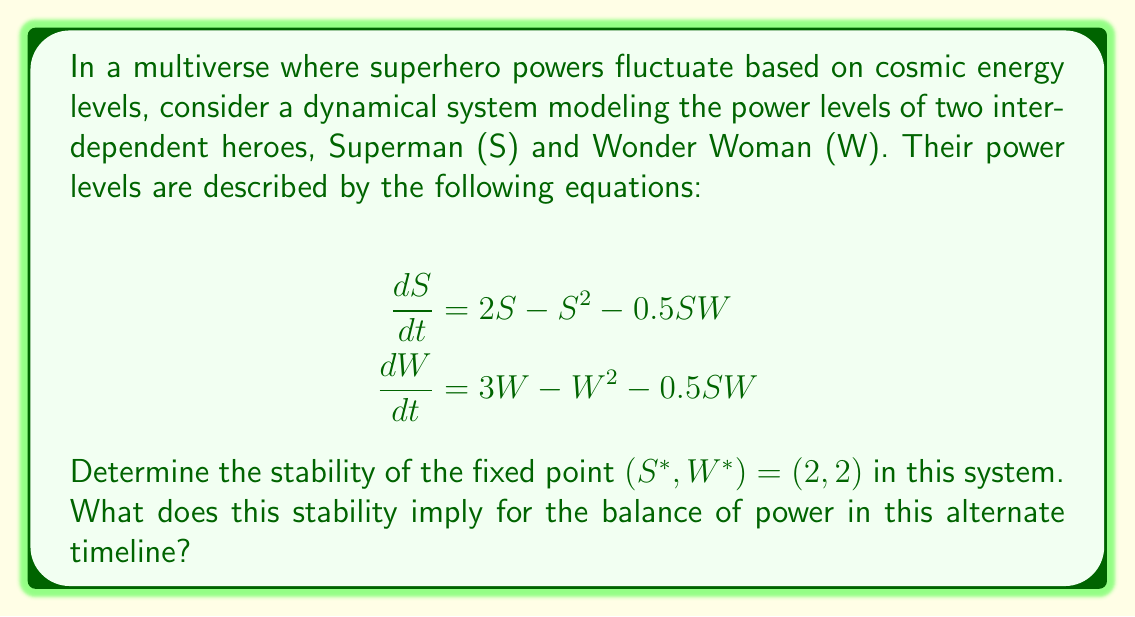Show me your answer to this math problem. To determine the stability of the fixed point (2, 2), we need to follow these steps:

1) First, we calculate the Jacobian matrix of the system at the fixed point:

   $$J = \begin{bmatrix}
   \frac{\partial}{\partial S}(2S - S^2 - 0.5SW) & \frac{\partial}{\partial W}(2S - S^2 - 0.5SW) \\
   \frac{\partial}{\partial S}(3W - W^2 - 0.5SW) & \frac{\partial}{\partial W}(3W - W^2 - 0.5SW)
   \end{bmatrix}$$

2) Evaluating the partial derivatives:

   $$J = \begin{bmatrix}
   2 - 2S - 0.5W & -0.5S \\
   -0.5W & 3 - 2W - 0.5S
   \end{bmatrix}$$

3) Substituting the fixed point (2, 2):

   $$J_{(2,2)} = \begin{bmatrix}
   2 - 2(2) - 0.5(2) & -0.5(2) \\
   -0.5(2) & 3 - 2(2) - 0.5(2)
   \end{bmatrix} = \begin{bmatrix}
   -3 & -1 \\
   -1 & -2
   \end{bmatrix}$$

4) To determine stability, we need to find the eigenvalues of this Jacobian matrix. The characteristic equation is:

   $$det(J_{(2,2)} - \lambda I) = \begin{vmatrix}
   -3-\lambda & -1 \\
   -1 & -2-\lambda
   \end{vmatrix} = 0$$

5) Expanding the determinant:

   $$(-3-\lambda)(-2-\lambda) - (-1)(-1) = 0$$
   $$\lambda^2 + 5\lambda + 5 = 0$$

6) Solving this quadratic equation:

   $$\lambda = \frac{-5 \pm \sqrt{25 - 20}}{2} = \frac{-5 \pm \sqrt{5}}{2}$$

7) The eigenvalues are:

   $$\lambda_1 = \frac{-5 + \sqrt{5}}{2} \approx -1.38$$
   $$\lambda_2 = \frac{-5 - \sqrt{5}}{2} \approx -3.62$$

8) Since both eigenvalues are negative real numbers, the fixed point (2, 2) is a stable node.

In the context of our superhero multiverse, this stability implies that in this alternate timeline, the power levels of Superman and Wonder Woman will tend to equilibrate at (2, 2) over time, regardless of small perturbations. This suggests a balanced and stable power dynamic between these two heroes in this particular universe.
Answer: Stable node 